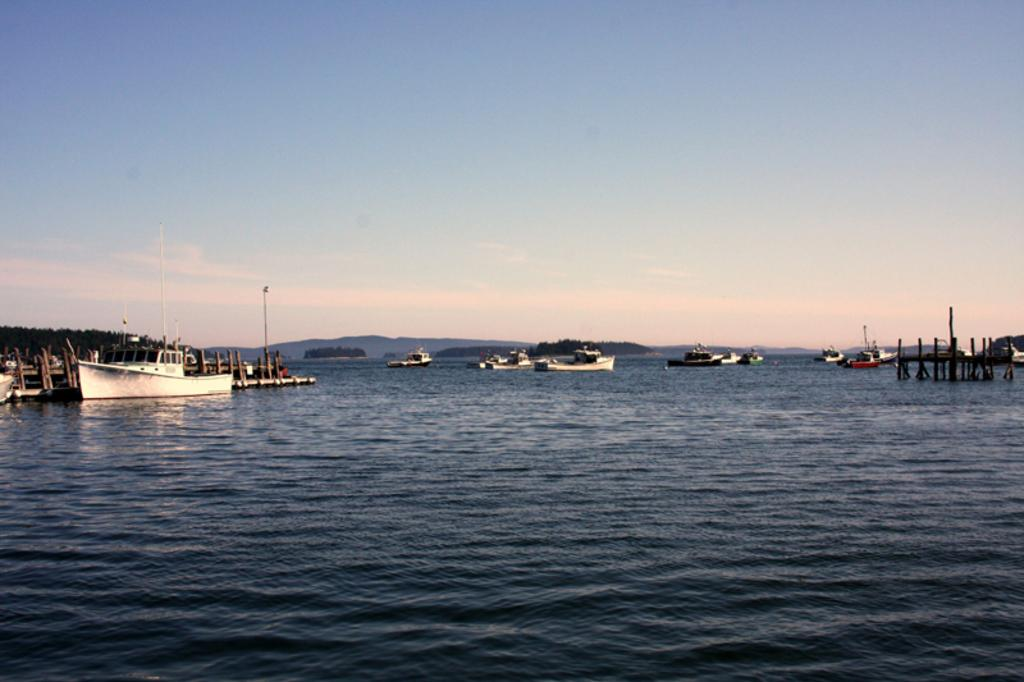What can be seen on the water in the image? There are ships on the ocean in the image. What type of poles are present in the image? There are wooden poles in the image. What type of vegetation is visible in the image? There are trees in the image. What type of geographical feature can be seen in the distance? There are mountains visible in the image. What part of the natural environment is visible in the image? The sky is visible in the image. What type of cakes are being sold by the carpenter on the trail in the image? There is no carpenter, cakes, or trail present in the image. 